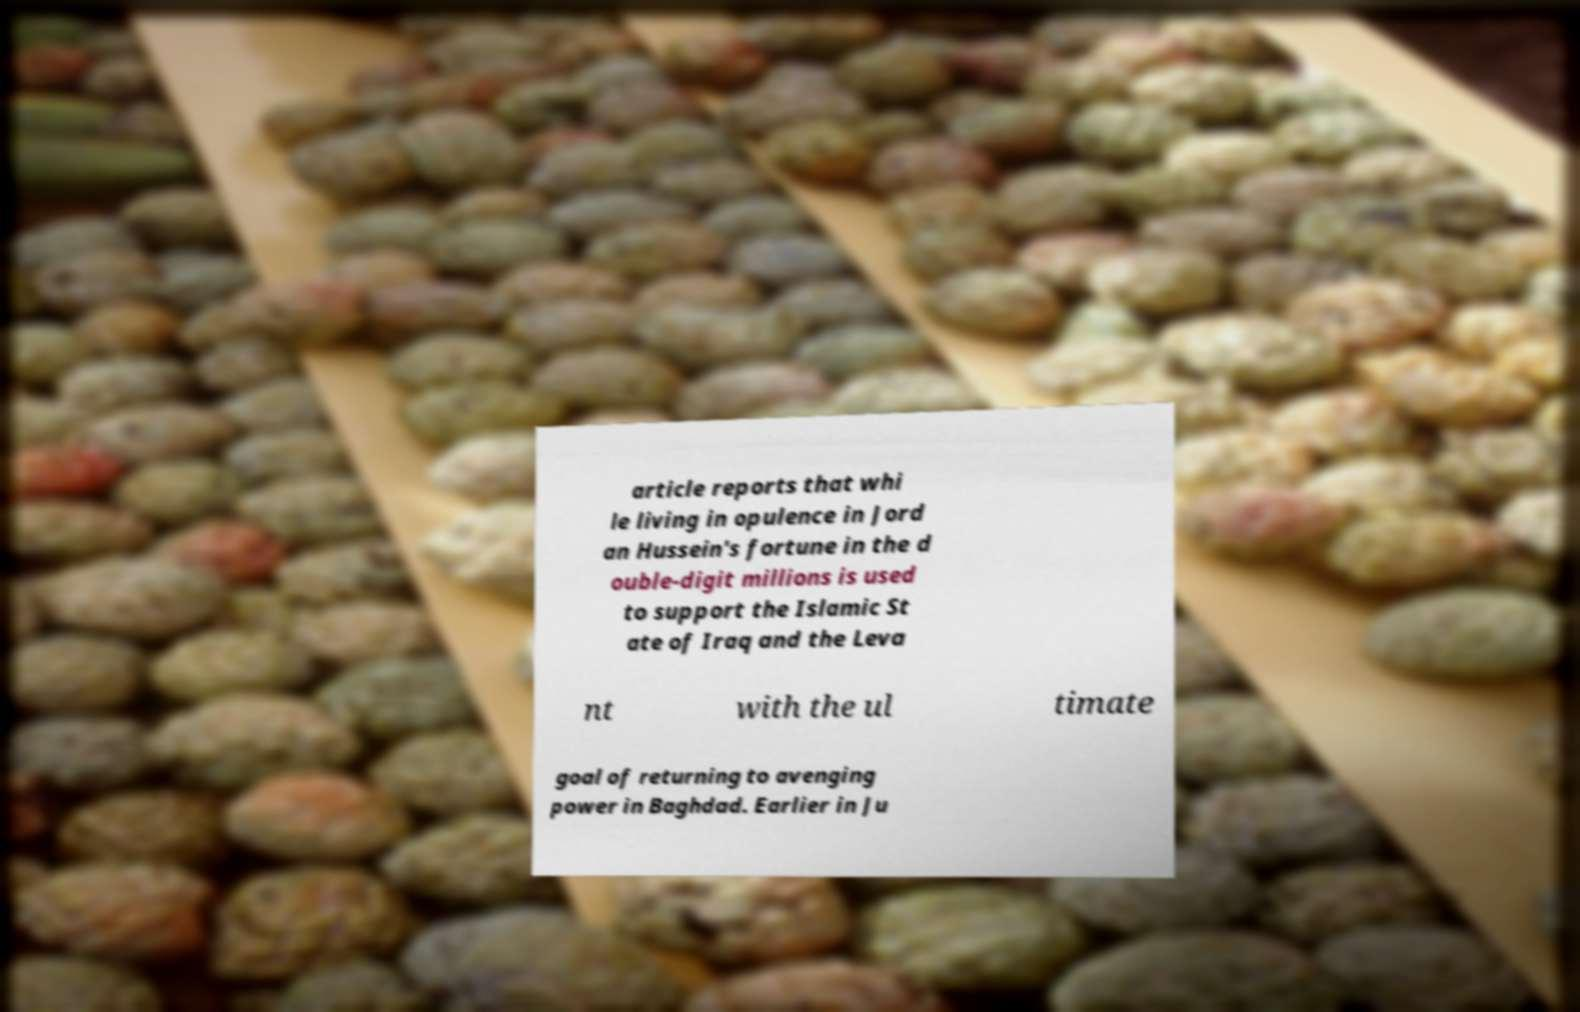Could you extract and type out the text from this image? article reports that whi le living in opulence in Jord an Hussein's fortune in the d ouble-digit millions is used to support the Islamic St ate of Iraq and the Leva nt with the ul timate goal of returning to avenging power in Baghdad. Earlier in Ju 